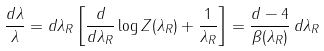<formula> <loc_0><loc_0><loc_500><loc_500>\frac { d \lambda } { \lambda } = d \lambda _ { R } \left [ \frac { d } { d \lambda _ { R } } \log Z ( \lambda _ { R } ) + \frac { 1 } { \lambda _ { R } } \right ] = \frac { d - 4 } { \beta ( \lambda _ { R } ) } \, d \lambda _ { R }</formula> 